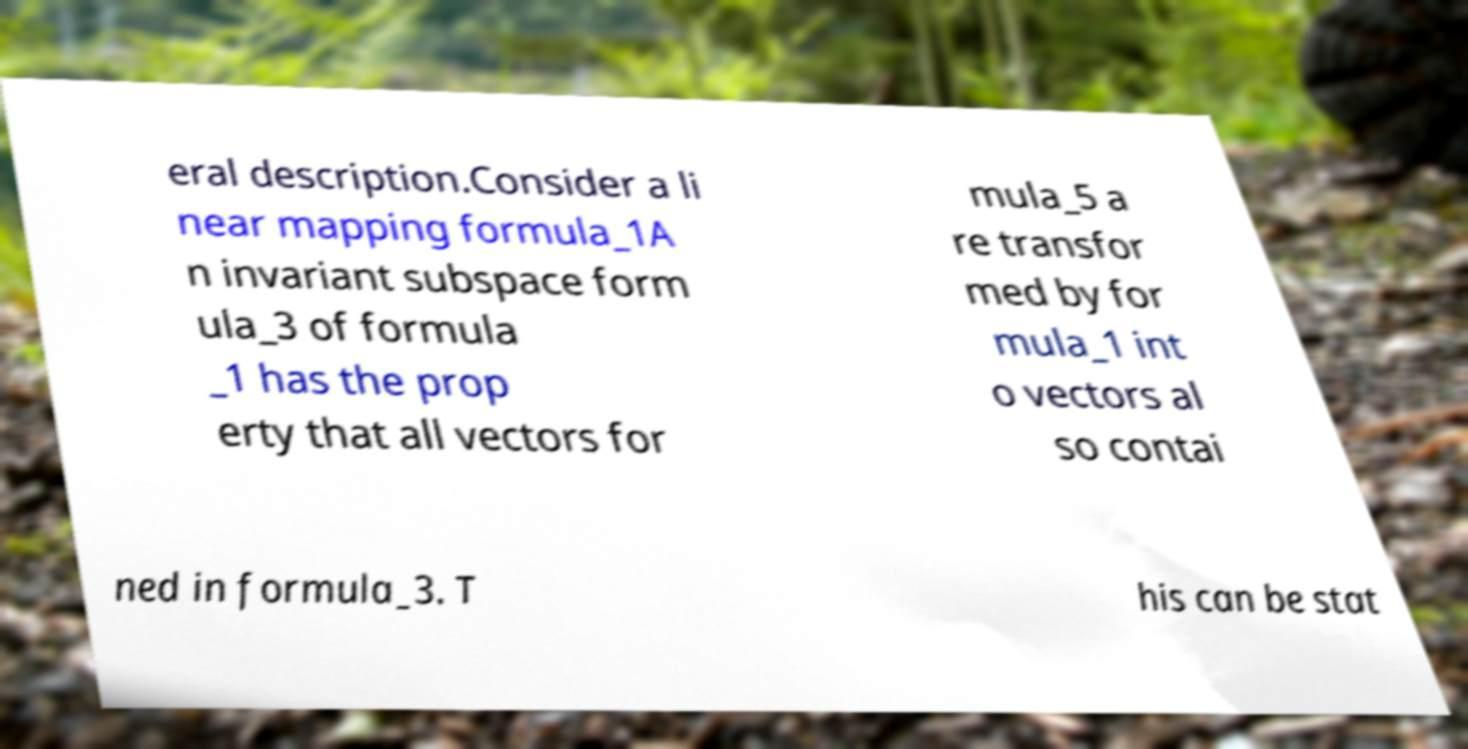Please read and relay the text visible in this image. What does it say? eral description.Consider a li near mapping formula_1A n invariant subspace form ula_3 of formula _1 has the prop erty that all vectors for mula_5 a re transfor med by for mula_1 int o vectors al so contai ned in formula_3. T his can be stat 